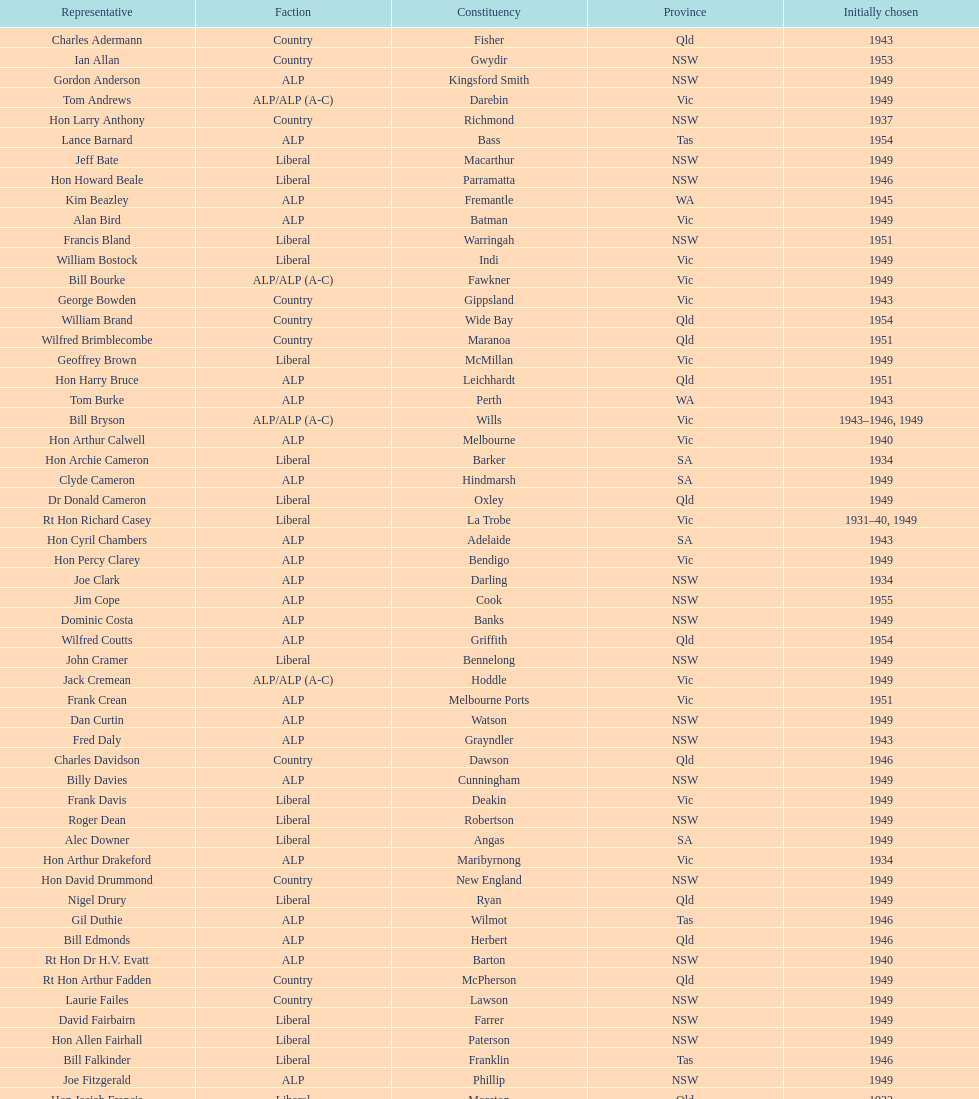Parse the table in full. {'header': ['Representative', 'Faction', 'Constituency', 'Province', 'Initially chosen'], 'rows': [['Charles Adermann', 'Country', 'Fisher', 'Qld', '1943'], ['Ian Allan', 'Country', 'Gwydir', 'NSW', '1953'], ['Gordon Anderson', 'ALP', 'Kingsford Smith', 'NSW', '1949'], ['Tom Andrews', 'ALP/ALP (A-C)', 'Darebin', 'Vic', '1949'], ['Hon Larry Anthony', 'Country', 'Richmond', 'NSW', '1937'], ['Lance Barnard', 'ALP', 'Bass', 'Tas', '1954'], ['Jeff Bate', 'Liberal', 'Macarthur', 'NSW', '1949'], ['Hon Howard Beale', 'Liberal', 'Parramatta', 'NSW', '1946'], ['Kim Beazley', 'ALP', 'Fremantle', 'WA', '1945'], ['Alan Bird', 'ALP', 'Batman', 'Vic', '1949'], ['Francis Bland', 'Liberal', 'Warringah', 'NSW', '1951'], ['William Bostock', 'Liberal', 'Indi', 'Vic', '1949'], ['Bill Bourke', 'ALP/ALP (A-C)', 'Fawkner', 'Vic', '1949'], ['George Bowden', 'Country', 'Gippsland', 'Vic', '1943'], ['William Brand', 'Country', 'Wide Bay', 'Qld', '1954'], ['Wilfred Brimblecombe', 'Country', 'Maranoa', 'Qld', '1951'], ['Geoffrey Brown', 'Liberal', 'McMillan', 'Vic', '1949'], ['Hon Harry Bruce', 'ALP', 'Leichhardt', 'Qld', '1951'], ['Tom Burke', 'ALP', 'Perth', 'WA', '1943'], ['Bill Bryson', 'ALP/ALP (A-C)', 'Wills', 'Vic', '1943–1946, 1949'], ['Hon Arthur Calwell', 'ALP', 'Melbourne', 'Vic', '1940'], ['Hon Archie Cameron', 'Liberal', 'Barker', 'SA', '1934'], ['Clyde Cameron', 'ALP', 'Hindmarsh', 'SA', '1949'], ['Dr Donald Cameron', 'Liberal', 'Oxley', 'Qld', '1949'], ['Rt Hon Richard Casey', 'Liberal', 'La Trobe', 'Vic', '1931–40, 1949'], ['Hon Cyril Chambers', 'ALP', 'Adelaide', 'SA', '1943'], ['Hon Percy Clarey', 'ALP', 'Bendigo', 'Vic', '1949'], ['Joe Clark', 'ALP', 'Darling', 'NSW', '1934'], ['Jim Cope', 'ALP', 'Cook', 'NSW', '1955'], ['Dominic Costa', 'ALP', 'Banks', 'NSW', '1949'], ['Wilfred Coutts', 'ALP', 'Griffith', 'Qld', '1954'], ['John Cramer', 'Liberal', 'Bennelong', 'NSW', '1949'], ['Jack Cremean', 'ALP/ALP (A-C)', 'Hoddle', 'Vic', '1949'], ['Frank Crean', 'ALP', 'Melbourne Ports', 'Vic', '1951'], ['Dan Curtin', 'ALP', 'Watson', 'NSW', '1949'], ['Fred Daly', 'ALP', 'Grayndler', 'NSW', '1943'], ['Charles Davidson', 'Country', 'Dawson', 'Qld', '1946'], ['Billy Davies', 'ALP', 'Cunningham', 'NSW', '1949'], ['Frank Davis', 'Liberal', 'Deakin', 'Vic', '1949'], ['Roger Dean', 'Liberal', 'Robertson', 'NSW', '1949'], ['Alec Downer', 'Liberal', 'Angas', 'SA', '1949'], ['Hon Arthur Drakeford', 'ALP', 'Maribyrnong', 'Vic', '1934'], ['Hon David Drummond', 'Country', 'New England', 'NSW', '1949'], ['Nigel Drury', 'Liberal', 'Ryan', 'Qld', '1949'], ['Gil Duthie', 'ALP', 'Wilmot', 'Tas', '1946'], ['Bill Edmonds', 'ALP', 'Herbert', 'Qld', '1946'], ['Rt Hon Dr H.V. Evatt', 'ALP', 'Barton', 'NSW', '1940'], ['Rt Hon Arthur Fadden', 'Country', 'McPherson', 'Qld', '1949'], ['Laurie Failes', 'Country', 'Lawson', 'NSW', '1949'], ['David Fairbairn', 'Liberal', 'Farrer', 'NSW', '1949'], ['Hon Allen Fairhall', 'Liberal', 'Paterson', 'NSW', '1949'], ['Bill Falkinder', 'Liberal', 'Franklin', 'Tas', '1946'], ['Joe Fitzgerald', 'ALP', 'Phillip', 'NSW', '1949'], ['Hon Josiah Francis', 'Liberal', 'Moreton', 'Qld', '1922'], ['Allan Fraser', 'ALP', 'Eden-Monaro', 'NSW', '1943'], ['Jim Fraser', 'ALP', 'Australian Capital Territory', 'ACT', '1951'], ['Gordon Freeth', 'Liberal', 'Forrest', 'WA', '1949'], ['Arthur Fuller', 'Country', 'Hume', 'NSW', '1943–49, 1951'], ['Pat Galvin', 'ALP', 'Kingston', 'SA', '1951'], ['Arthur Greenup', 'ALP', 'Dalley', 'NSW', '1953'], ['Charles Griffiths', 'ALP', 'Shortland', 'NSW', '1949'], ['Jo Gullett', 'Liberal', 'Henty', 'Vic', '1946'], ['Len Hamilton', 'Country', 'Canning', 'WA', '1946'], ['Rt Hon Eric Harrison', 'Liberal', 'Wentworth', 'NSW', '1931'], ['Jim Harrison', 'ALP', 'Blaxland', 'NSW', '1949'], ['Hon Paul Hasluck', 'Liberal', 'Curtin', 'WA', '1949'], ['Hon William Haworth', 'Liberal', 'Isaacs', 'Vic', '1949'], ['Leslie Haylen', 'ALP', 'Parkes', 'NSW', '1943'], ['Rt Hon Harold Holt', 'Liberal', 'Higgins', 'Vic', '1935'], ['John Howse', 'Liberal', 'Calare', 'NSW', '1946'], ['Alan Hulme', 'Liberal', 'Petrie', 'Qld', '1949'], ['William Jack', 'Liberal', 'North Sydney', 'NSW', '1949'], ['Rowley James', 'ALP', 'Hunter', 'NSW', '1928'], ['Hon Herbert Johnson', 'ALP', 'Kalgoorlie', 'WA', '1940'], ['Bob Joshua', 'ALP/ALP (A-C)', 'Ballaarat', 'ALP', '1951'], ['Percy Joske', 'Liberal', 'Balaclava', 'Vic', '1951'], ['Hon Wilfrid Kent Hughes', 'Liberal', 'Chisholm', 'Vic', '1949'], ['Stan Keon', 'ALP/ALP (A-C)', 'Yarra', 'Vic', '1949'], ['William Lawrence', 'Liberal', 'Wimmera', 'Vic', '1949'], ['Hon George Lawson', 'ALP', 'Brisbane', 'Qld', '1931'], ['Nelson Lemmon', 'ALP', 'St George', 'NSW', '1943–49, 1954'], ['Hugh Leslie', 'Liberal', 'Moore', 'Country', '1949'], ['Robert Lindsay', 'Liberal', 'Flinders', 'Vic', '1954'], ['Tony Luchetti', 'ALP', 'Macquarie', 'NSW', '1951'], ['Aubrey Luck', 'Liberal', 'Darwin', 'Tas', '1951'], ['Philip Lucock', 'Country', 'Lyne', 'NSW', '1953'], ['Dan Mackinnon', 'Liberal', 'Corangamite', 'Vic', '1949–51, 1953'], ['Hon Norman Makin', 'ALP', 'Sturt', 'SA', '1919–46, 1954'], ['Hon Philip McBride', 'Liberal', 'Wakefield', 'SA', '1931–37, 1937–43 (S), 1946'], ['Malcolm McColm', 'Liberal', 'Bowman', 'Qld', '1949'], ['Rt Hon John McEwen', 'Country', 'Murray', 'Vic', '1934'], ['John McLeay', 'Liberal', 'Boothby', 'SA', '1949'], ['Don McLeod', 'Liberal', 'Wannon', 'ALP', '1940–49, 1951'], ['Hon William McMahon', 'Liberal', 'Lowe', 'NSW', '1949'], ['Rt Hon Robert Menzies', 'Liberal', 'Kooyong', 'Vic', '1934'], ['Dan Minogue', 'ALP', 'West Sydney', 'NSW', '1949'], ['Charles Morgan', 'ALP', 'Reid', 'NSW', '1940–46, 1949'], ['Jack Mullens', 'ALP/ALP (A-C)', 'Gellibrand', 'Vic', '1949'], ['Jock Nelson', 'ALP', 'Northern Territory', 'NT', '1949'], ["William O'Connor", 'ALP', 'Martin', 'NSW', '1946'], ['Hubert Opperman', 'Liberal', 'Corio', 'Vic', '1949'], ['Hon Frederick Osborne', 'Liberal', 'Evans', 'NSW', '1949'], ['Rt Hon Sir Earle Page', 'Country', 'Cowper', 'NSW', '1919'], ['Henry Pearce', 'Liberal', 'Capricornia', 'Qld', '1949'], ['Ted Peters', 'ALP', 'Burke', 'Vic', '1949'], ['Hon Reg Pollard', 'ALP', 'Lalor', 'Vic', '1937'], ['Hon Bill Riordan', 'ALP', 'Kennedy', 'Qld', '1936'], ['Hugh Roberton', 'Country', 'Riverina', 'NSW', '1949'], ['Edgar Russell', 'ALP', 'Grey', 'SA', '1943'], ['Tom Sheehan', 'ALP', 'Cook', 'NSW', '1937'], ['Frank Stewart', 'ALP', 'Lang', 'NSW', '1953'], ['Reginald Swartz', 'Liberal', 'Darling Downs', 'Qld', '1949'], ['Albert Thompson', 'ALP', 'Port Adelaide', 'SA', '1946'], ['Frank Timson', 'Liberal', 'Higinbotham', 'Vic', '1949'], ['Hon Athol Townley', 'Liberal', 'Denison', 'Tas', '1949'], ['Winton Turnbull', 'Country', 'Mallee', 'Vic', '1946'], ['Harry Turner', 'Liberal', 'Bradfield', 'NSW', '1952'], ['Hon Eddie Ward', 'ALP', 'East Sydney', 'NSW', '1931, 1932'], ['David Oliver Watkins', 'ALP', 'Newcastle', 'NSW', '1935'], ['Harry Webb', 'ALP', 'Swan', 'WA', '1954'], ['William Wentworth', 'Liberal', 'Mackellar', 'NSW', '1949'], ['Roy Wheeler', 'Liberal', 'Mitchell', 'NSW', '1949'], ['Gough Whitlam', 'ALP', 'Werriwa', 'NSW', '1952'], ['Bruce Wight', 'Liberal', 'Lilley', 'Qld', '1949']]} Who was the first member to be elected? Charles Adermann. 